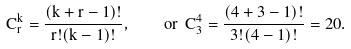<formula> <loc_0><loc_0><loc_500><loc_500>C ^ { k } _ { r } = \frac { ( k + r - 1 ) ! } { r ! ( k - 1 ) ! } , \quad o r \ C ^ { 4 } _ { 3 } = \frac { ( 4 + 3 - 1 ) ! } { 3 ! ( 4 - 1 ) ! } = 2 0 .</formula> 